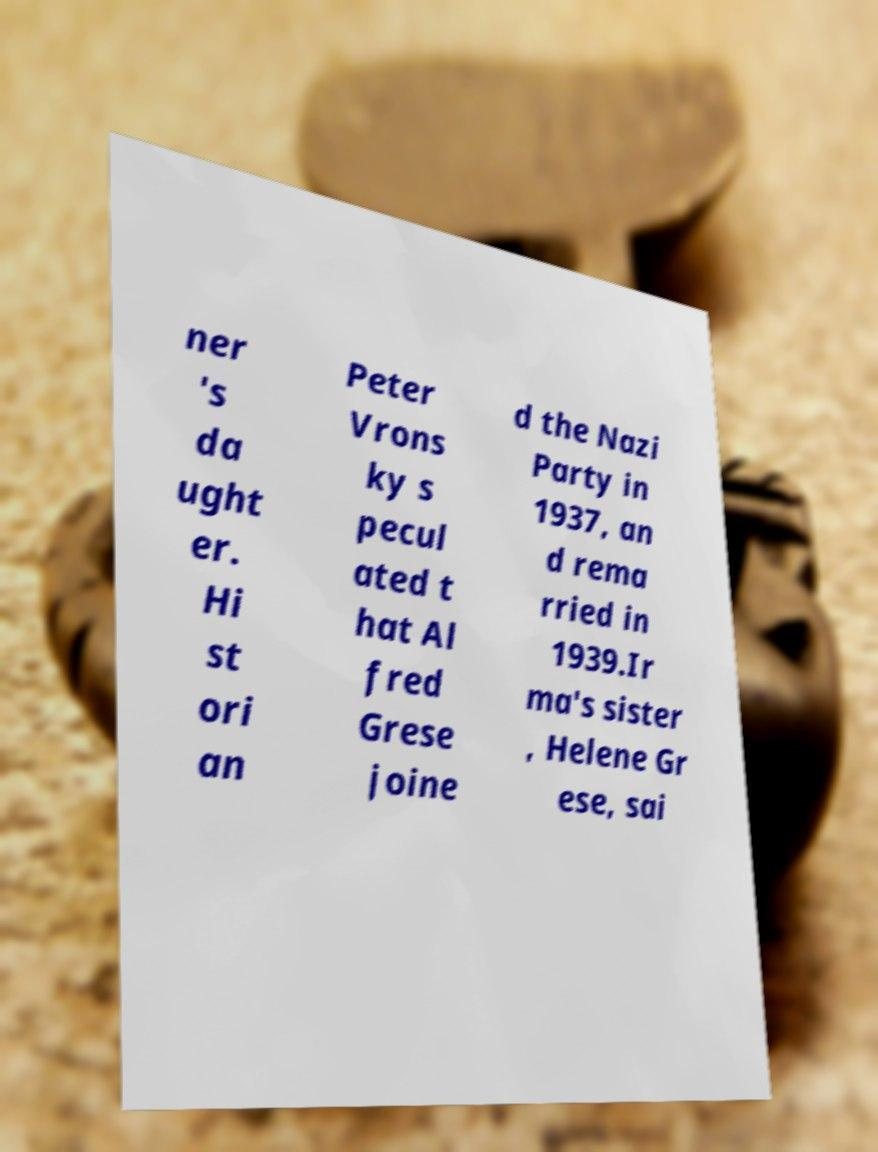There's text embedded in this image that I need extracted. Can you transcribe it verbatim? ner 's da ught er. Hi st ori an Peter Vrons ky s pecul ated t hat Al fred Grese joine d the Nazi Party in 1937, an d rema rried in 1939.Ir ma's sister , Helene Gr ese, sai 